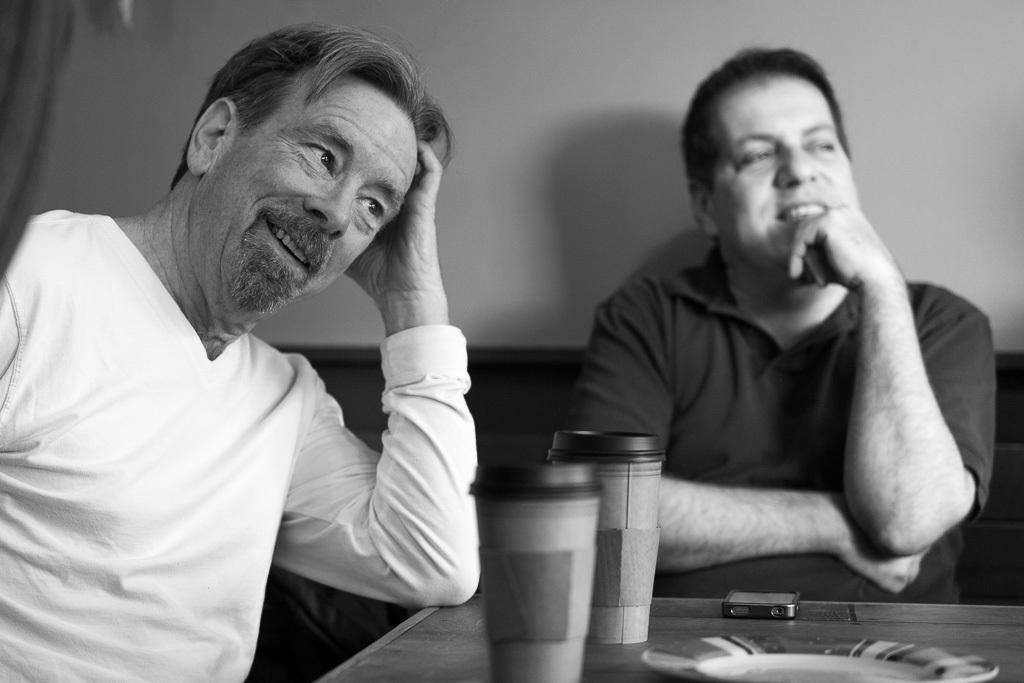What is the color scheme of the image? The image is black and white. How many people are in the image? There are two men sitting in the image. What is in front of the men? There is a table in front of the men. What items can be seen on the table? There is a plate, two glasses, and a mobile phone on the table. What type of yak can be seen grazing on the top of the cloud in the image? There is no yak or cloud present in the image; it is a black and white image of two men sitting at a table. 